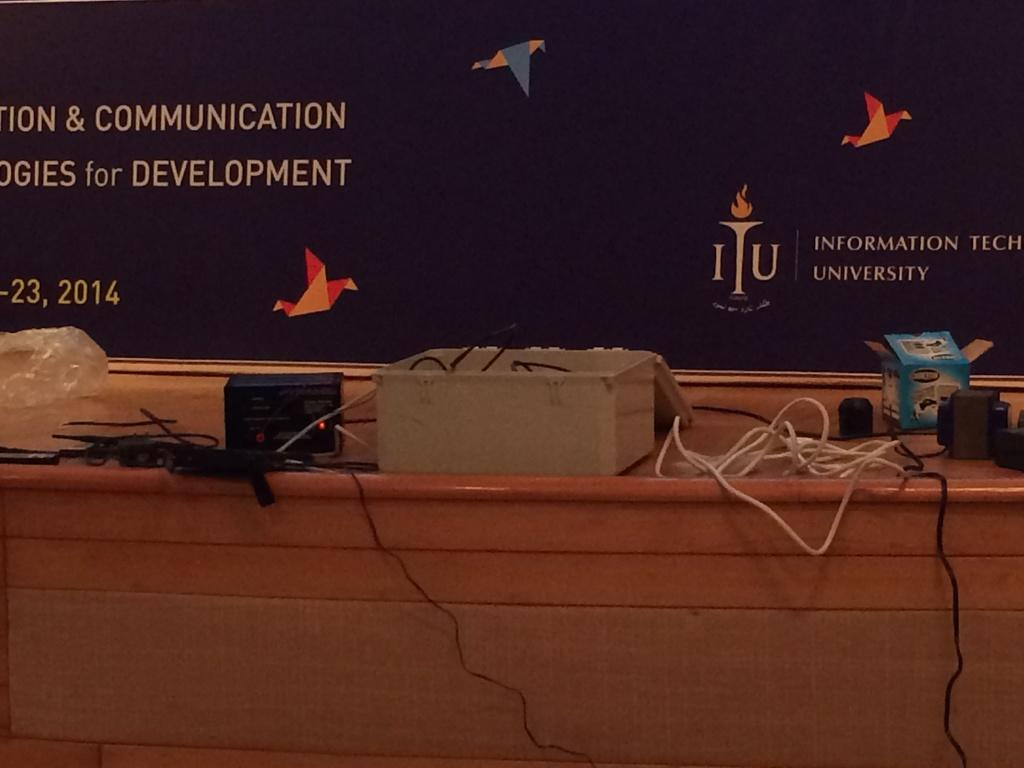What piece of furniture is present in the image? There is a desk in the image. What is on top of the desk? There are things placed on the desk. What color is the poster visible in the image? There is a blue poster visible in the image. What direction is the baby facing in the image? There is no baby present in the image. 